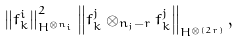<formula> <loc_0><loc_0><loc_500><loc_500>\left \| f _ { k } ^ { i } \right \| _ { H ^ { \otimes n _ { i } } } ^ { 2 } \left \| f _ { k } ^ { j } \otimes _ { n _ { j } - r } f _ { k } ^ { j } \right \| _ { H ^ { \otimes ( 2 r ) } } ,</formula> 